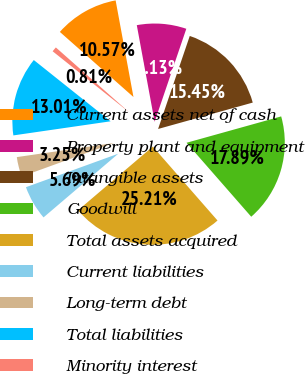Convert chart to OTSL. <chart><loc_0><loc_0><loc_500><loc_500><pie_chart><fcel>Current assets net of cash<fcel>Property plant and equipment<fcel>Intangible assets<fcel>Goodwill<fcel>Total assets acquired<fcel>Current liabilities<fcel>Long-term debt<fcel>Total liabilities<fcel>Minority interest<nl><fcel>10.57%<fcel>8.13%<fcel>15.45%<fcel>17.89%<fcel>25.21%<fcel>5.69%<fcel>3.25%<fcel>13.01%<fcel>0.81%<nl></chart> 